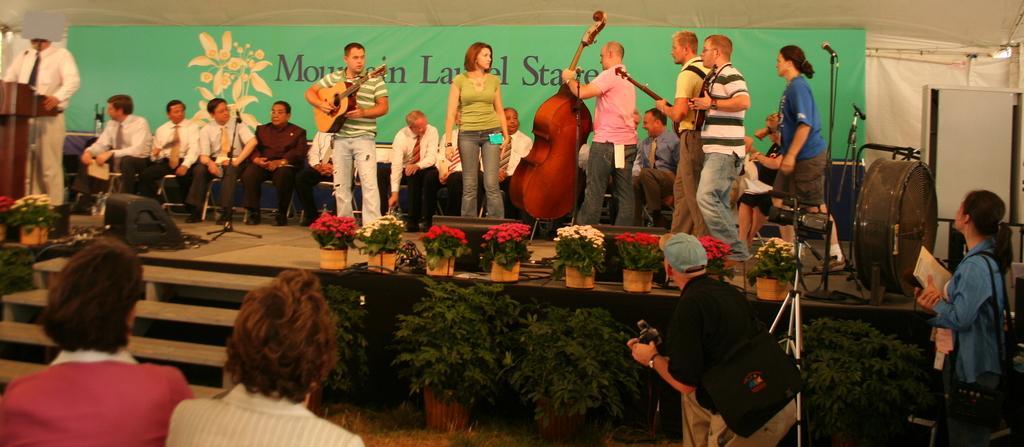Can you describe this image briefly? In the image in the center, we can see one stage. On the stage, we can see few people are standing and holding guitars. And we can see plant pots, flowers, musical instruments, one banner, one stand, microphones and few people are sitting on the chair. In the bottom of the image, we can see a few people standing and holding some objects. And we can see one camera and staircase. 